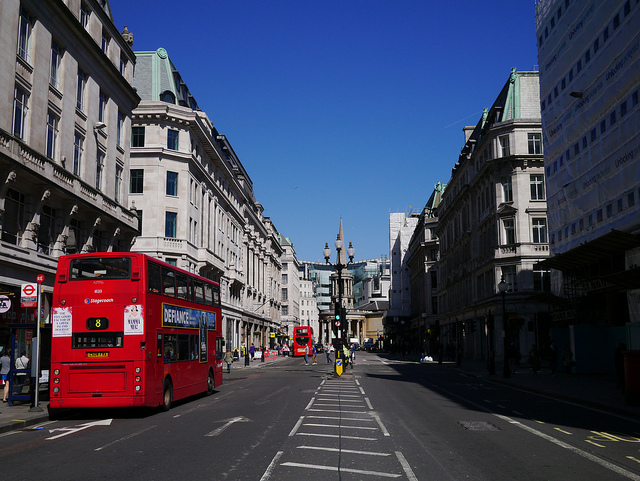Can you describe the architecture of the buildings seen on the right side of the street? Certainly! The buildings on the right showcase a classical architectural style common in European cities. They feature clean lines, with detailed cornicing and stonework. The windows are regularly spaced, and the roofs are pitched slightly, alluding to a Georgian or Victorian design element. 